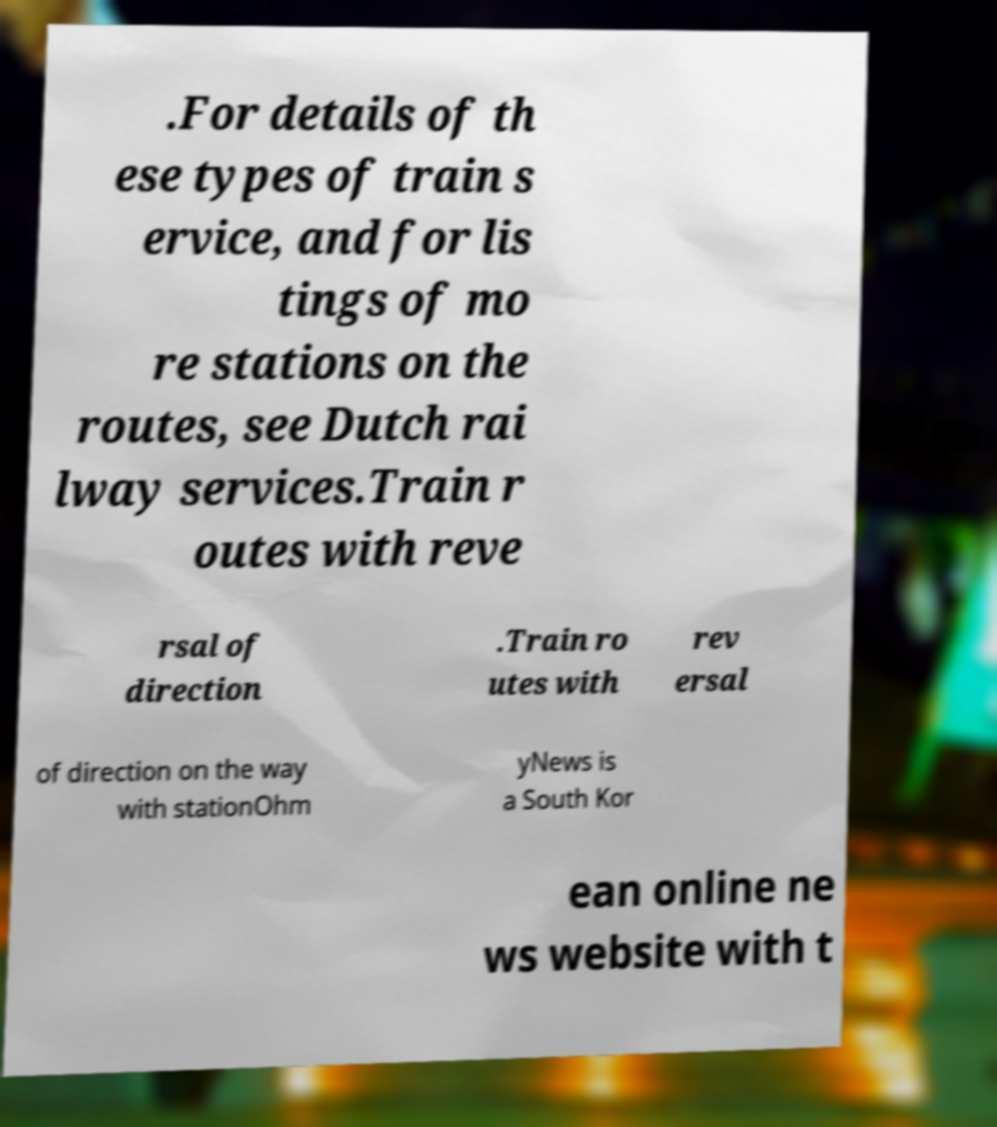Please identify and transcribe the text found in this image. .For details of th ese types of train s ervice, and for lis tings of mo re stations on the routes, see Dutch rai lway services.Train r outes with reve rsal of direction .Train ro utes with rev ersal of direction on the way with stationOhm yNews is a South Kor ean online ne ws website with t 